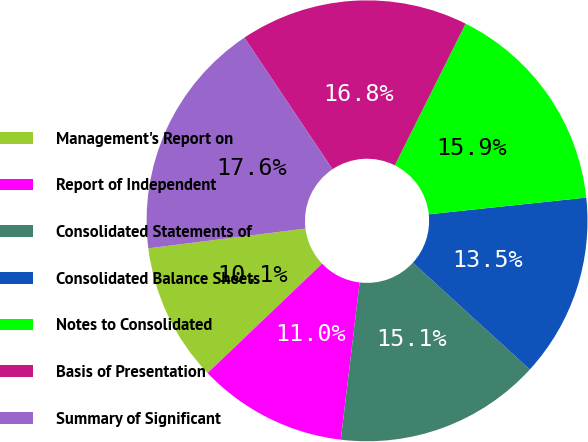<chart> <loc_0><loc_0><loc_500><loc_500><pie_chart><fcel>Management's Report on<fcel>Report of Independent<fcel>Consolidated Statements of<fcel>Consolidated Balance Sheets<fcel>Notes to Consolidated<fcel>Basis of Presentation<fcel>Summary of Significant<nl><fcel>10.14%<fcel>10.97%<fcel>15.12%<fcel>13.46%<fcel>15.94%<fcel>16.77%<fcel>17.6%<nl></chart> 